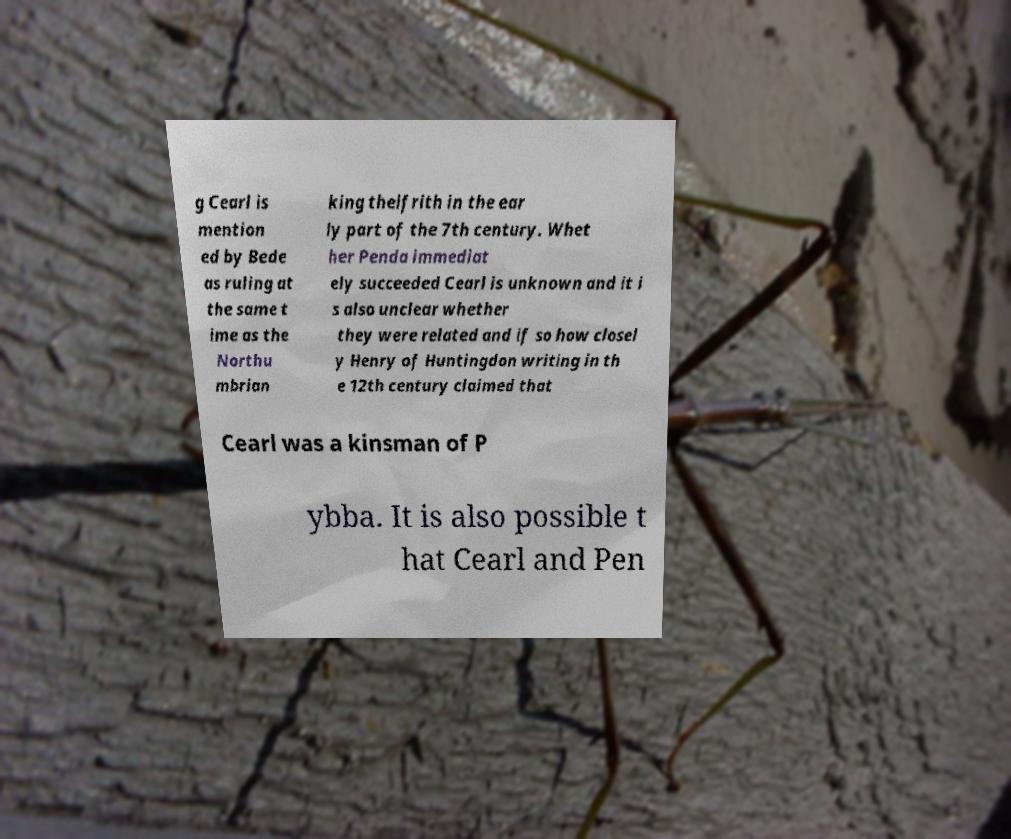Please read and relay the text visible in this image. What does it say? g Cearl is mention ed by Bede as ruling at the same t ime as the Northu mbrian king thelfrith in the ear ly part of the 7th century. Whet her Penda immediat ely succeeded Cearl is unknown and it i s also unclear whether they were related and if so how closel y Henry of Huntingdon writing in th e 12th century claimed that Cearl was a kinsman of P ybba. It is also possible t hat Cearl and Pen 